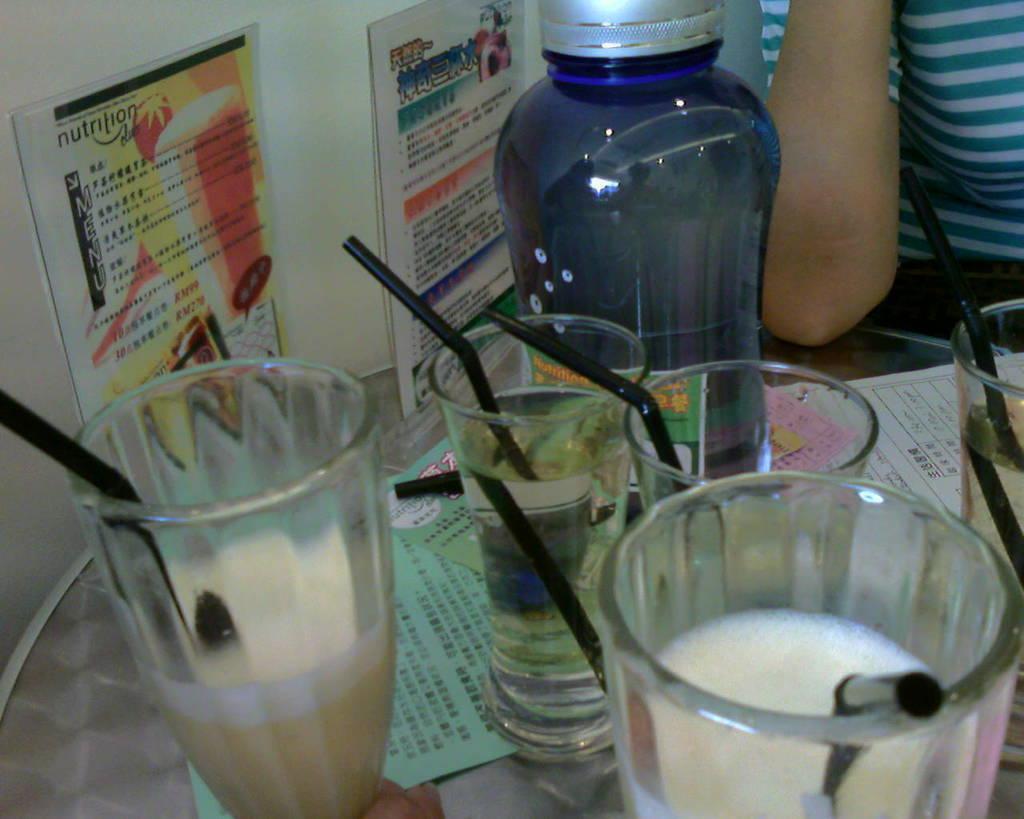In one or two sentences, can you explain what this image depicts? On the table we have glass,bottle,paper and on the wall posters,person sitting. 